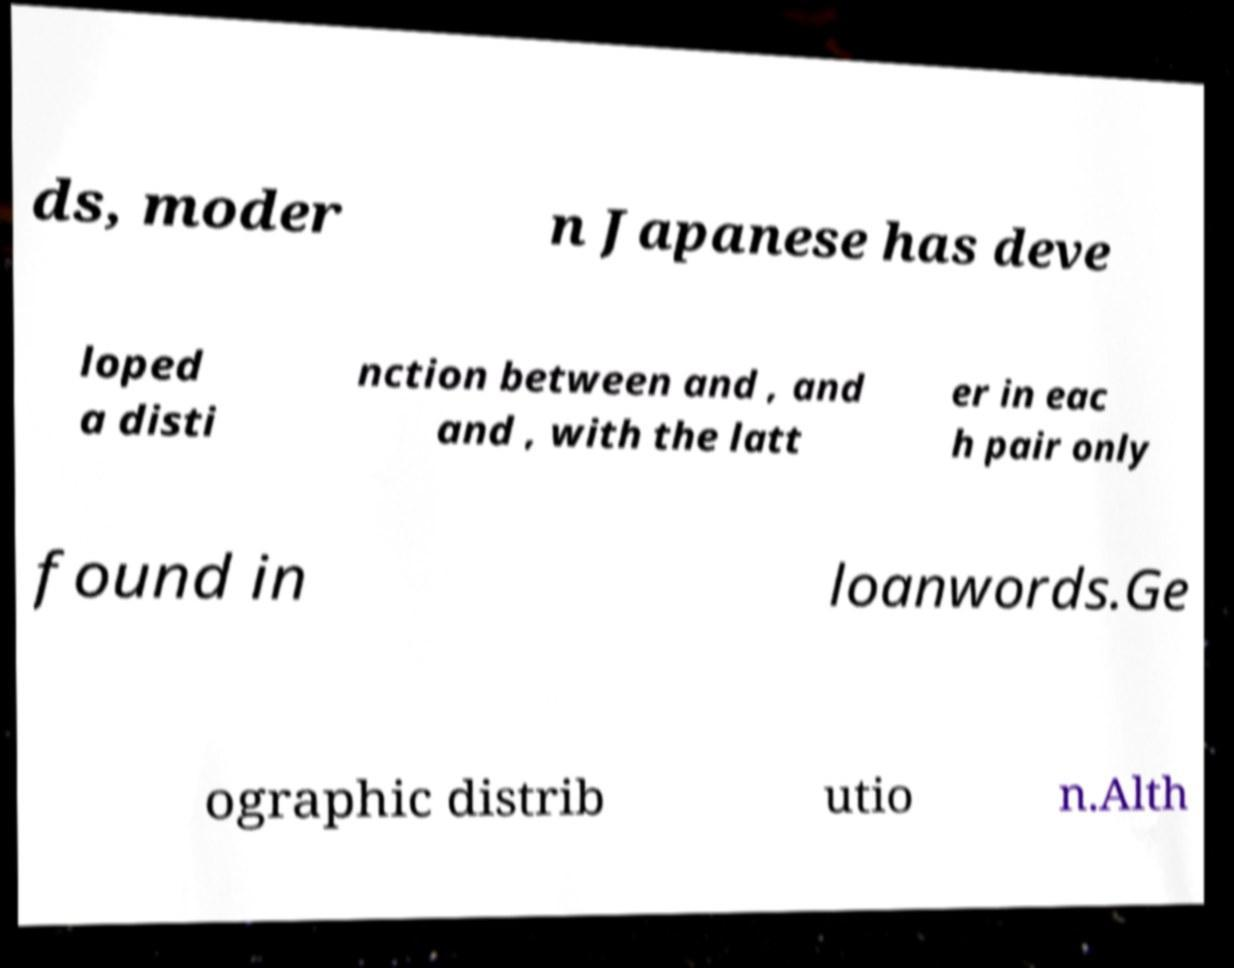I need the written content from this picture converted into text. Can you do that? ds, moder n Japanese has deve loped a disti nction between and , and and , with the latt er in eac h pair only found in loanwords.Ge ographic distrib utio n.Alth 